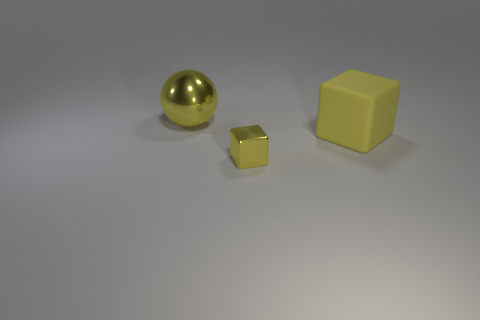Add 2 large gray rubber objects. How many objects exist? 5 Subtract all blocks. How many objects are left? 1 Add 1 small green rubber cylinders. How many small green rubber cylinders exist? 1 Subtract 0 red blocks. How many objects are left? 3 Subtract all small yellow shiny things. Subtract all large yellow objects. How many objects are left? 0 Add 2 big cubes. How many big cubes are left? 3 